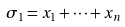Convert formula to latex. <formula><loc_0><loc_0><loc_500><loc_500>\sigma _ { 1 } = x _ { 1 } + \cdots + x _ { n }</formula> 